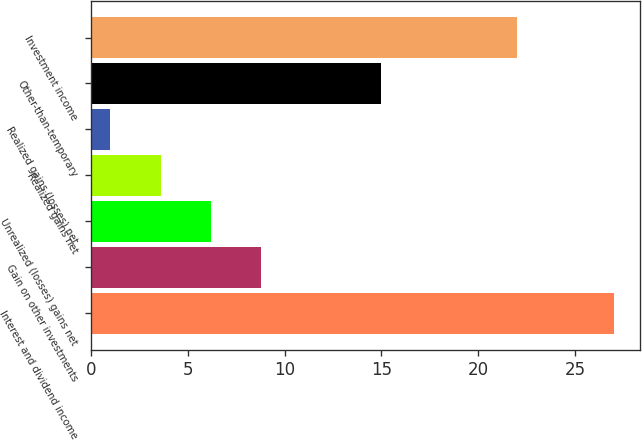Convert chart. <chart><loc_0><loc_0><loc_500><loc_500><bar_chart><fcel>Interest and dividend income<fcel>Gain on other investments<fcel>Unrealized (losses) gains net<fcel>Realized gains net<fcel>Realized gains (losses) net<fcel>Other-than-temporary<fcel>Investment income<nl><fcel>27<fcel>8.8<fcel>6.2<fcel>3.6<fcel>1<fcel>15<fcel>22<nl></chart> 